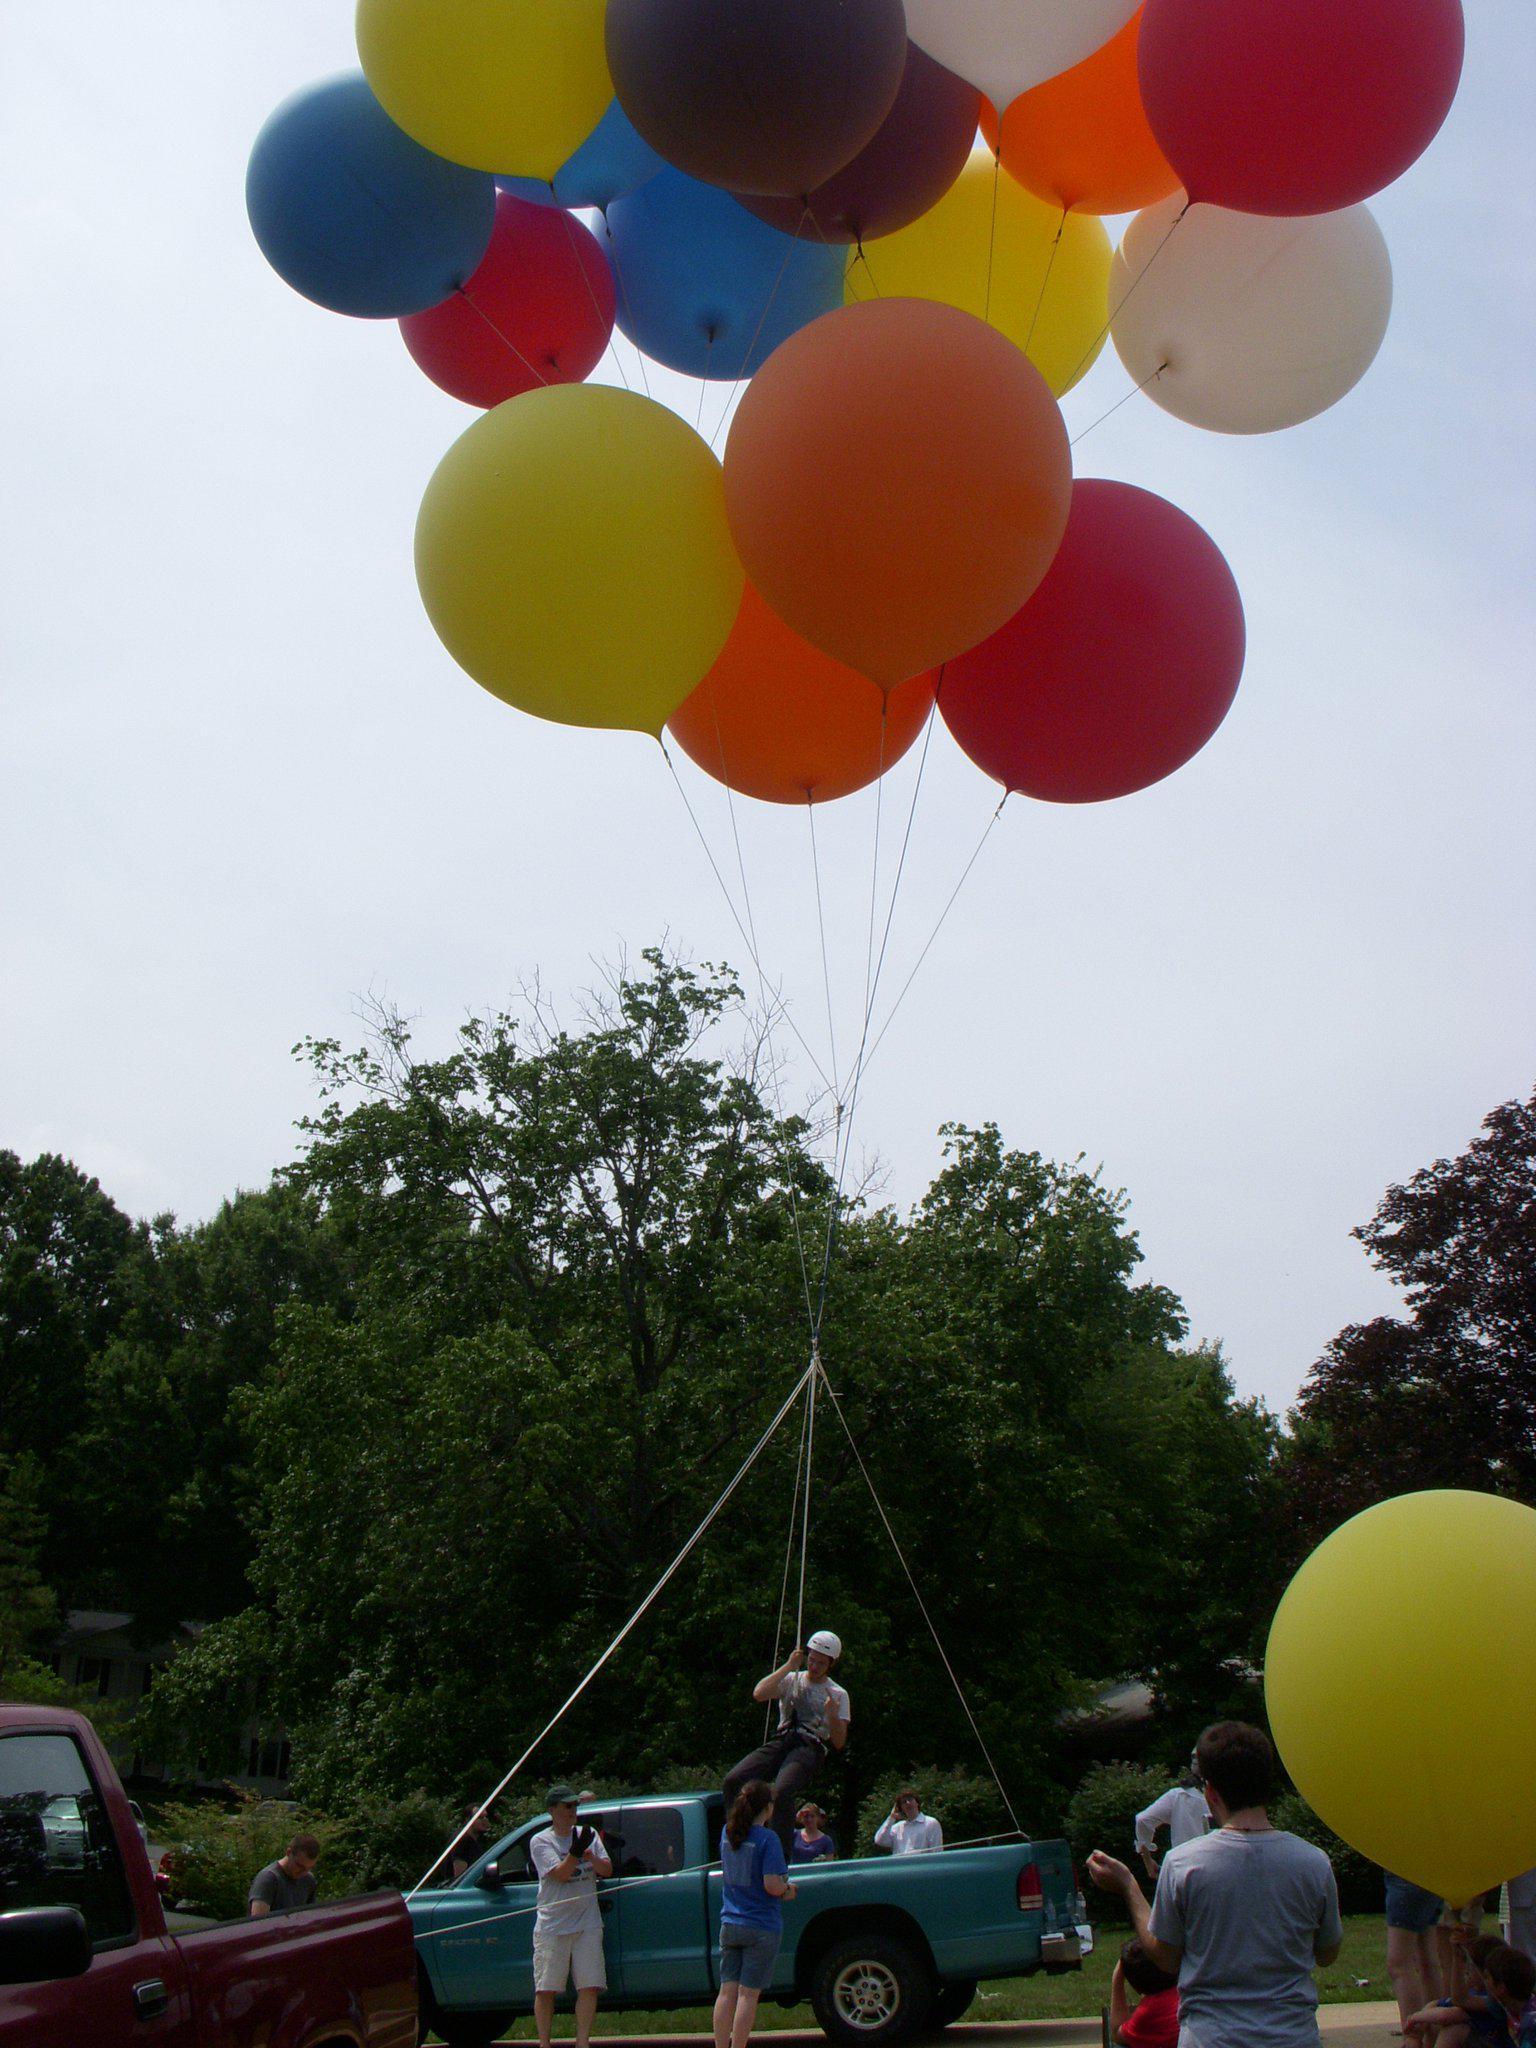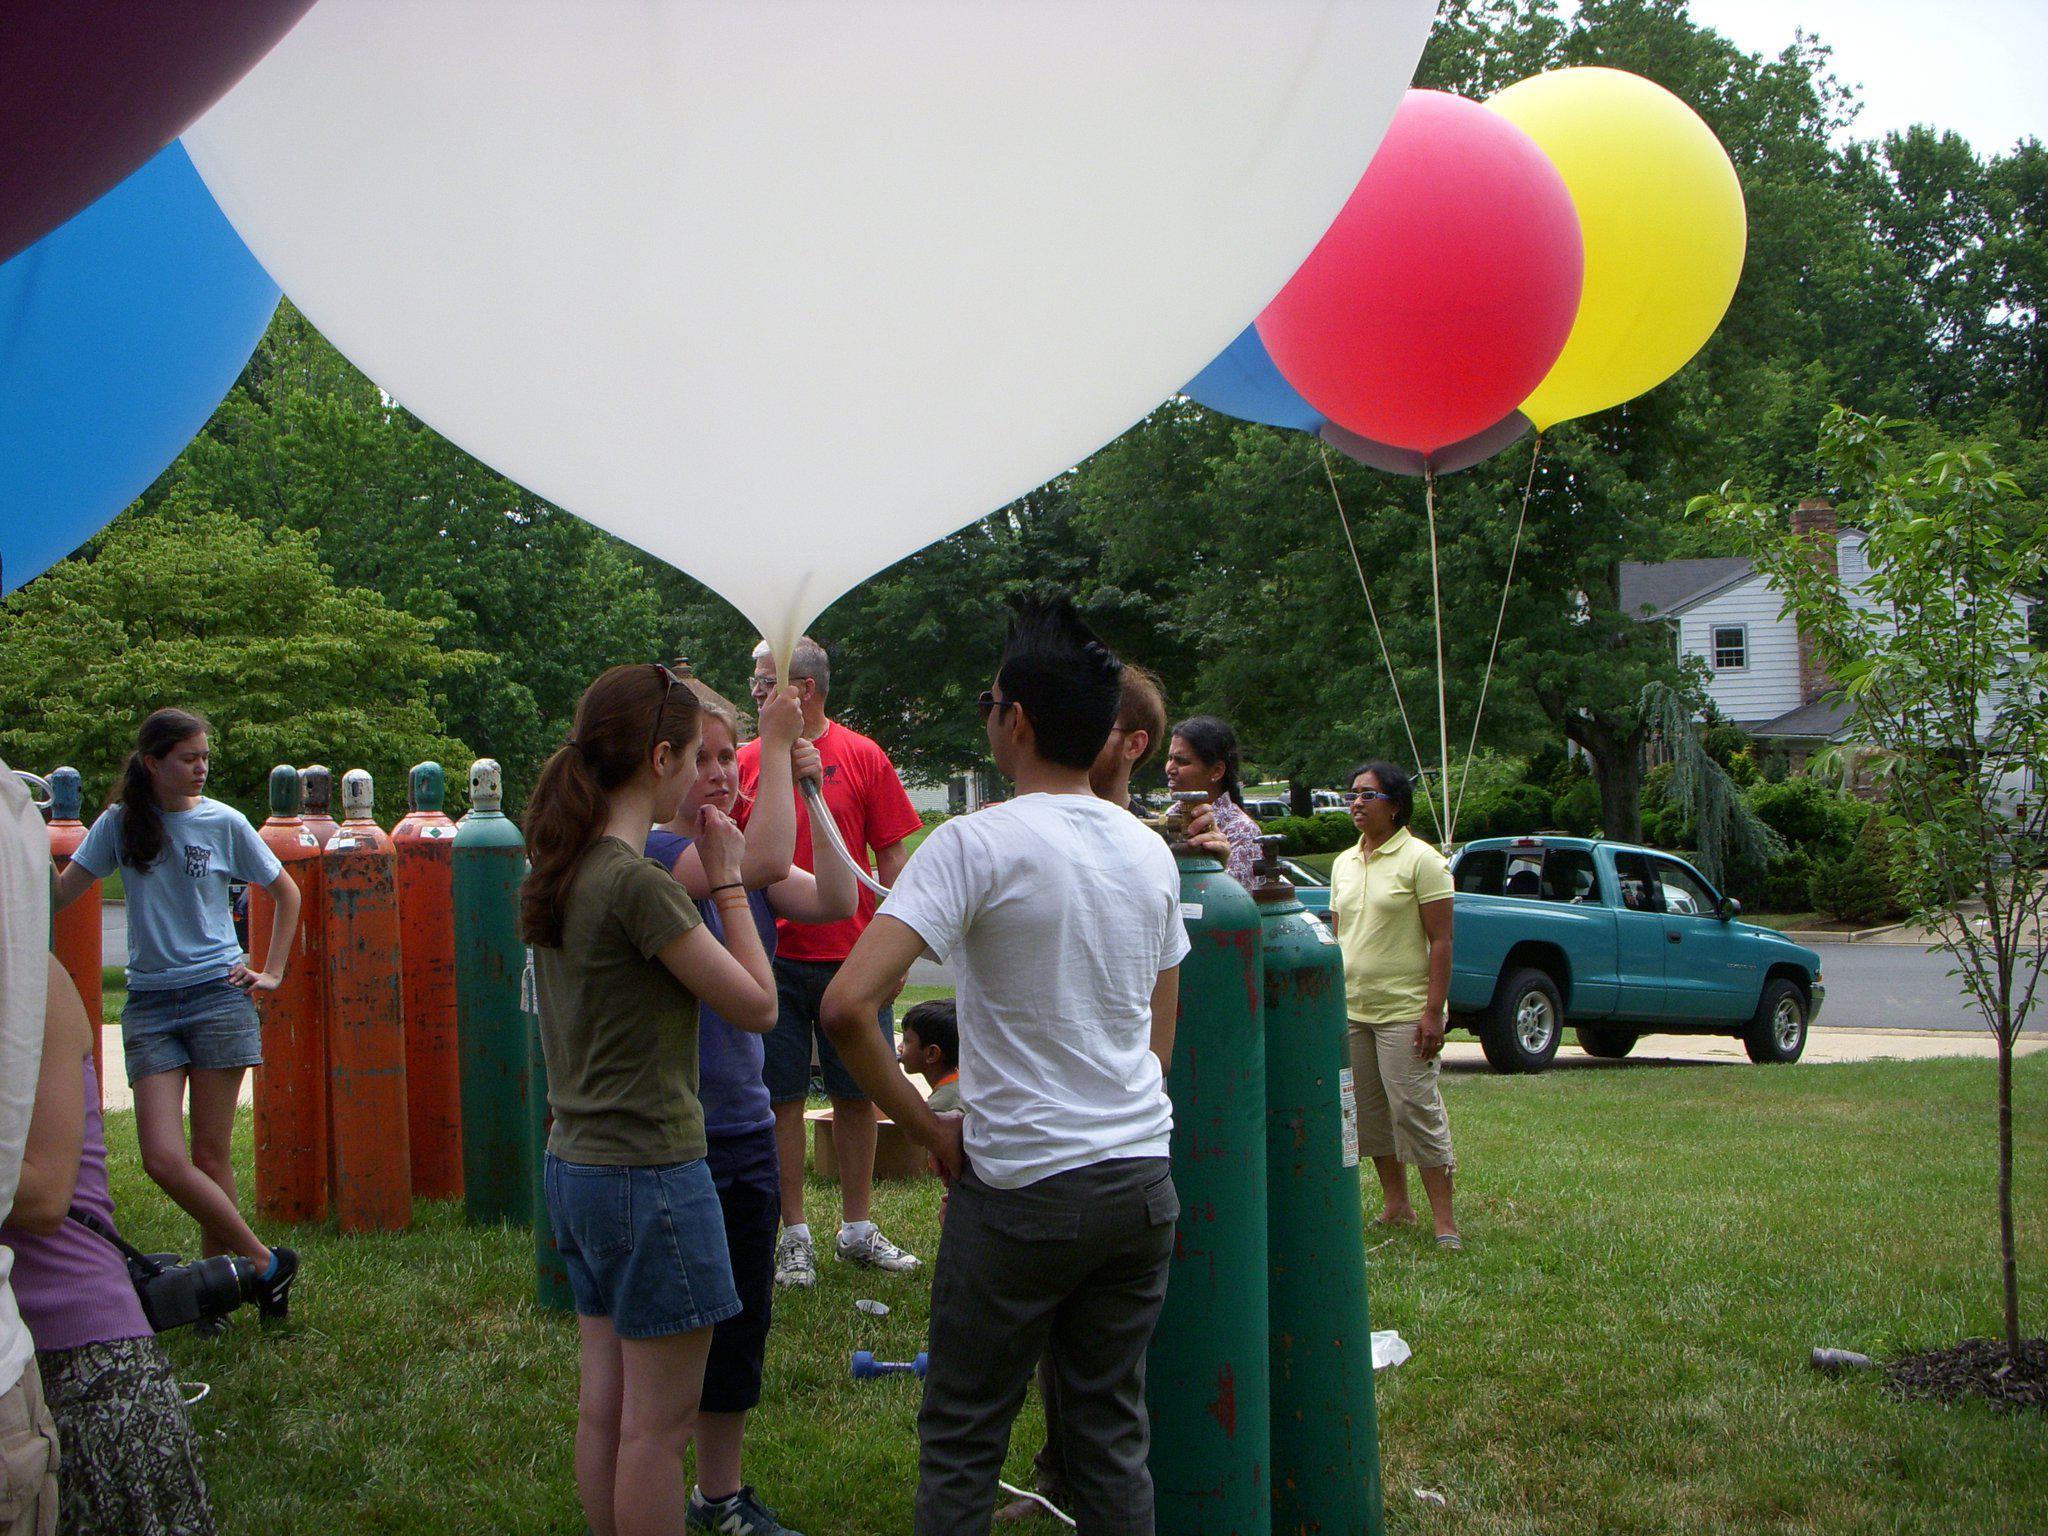The first image is the image on the left, the second image is the image on the right. Given the left and right images, does the statement "There are three bunches of balloons." hold true? Answer yes or no. No. The first image is the image on the left, the second image is the image on the right. Evaluate the accuracy of this statement regarding the images: "Two balloon bunches containing at least a dozen balloons each are in the air in one image.". Is it true? Answer yes or no. No. 